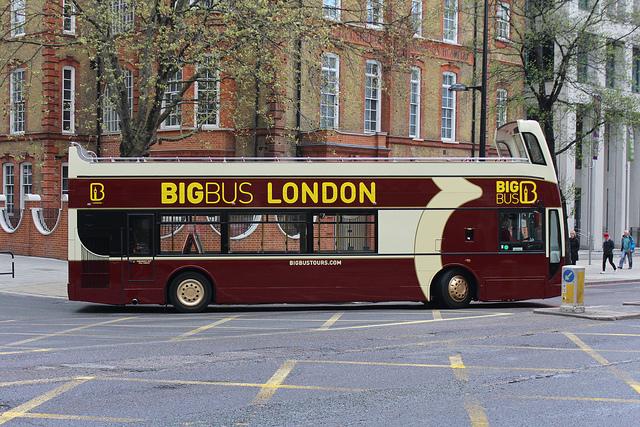What city does this bus operate in?
Quick response, please. London. Are there people on the bus?
Keep it brief. No. What does the bus have written on it?
Keep it brief. Big bus london. 